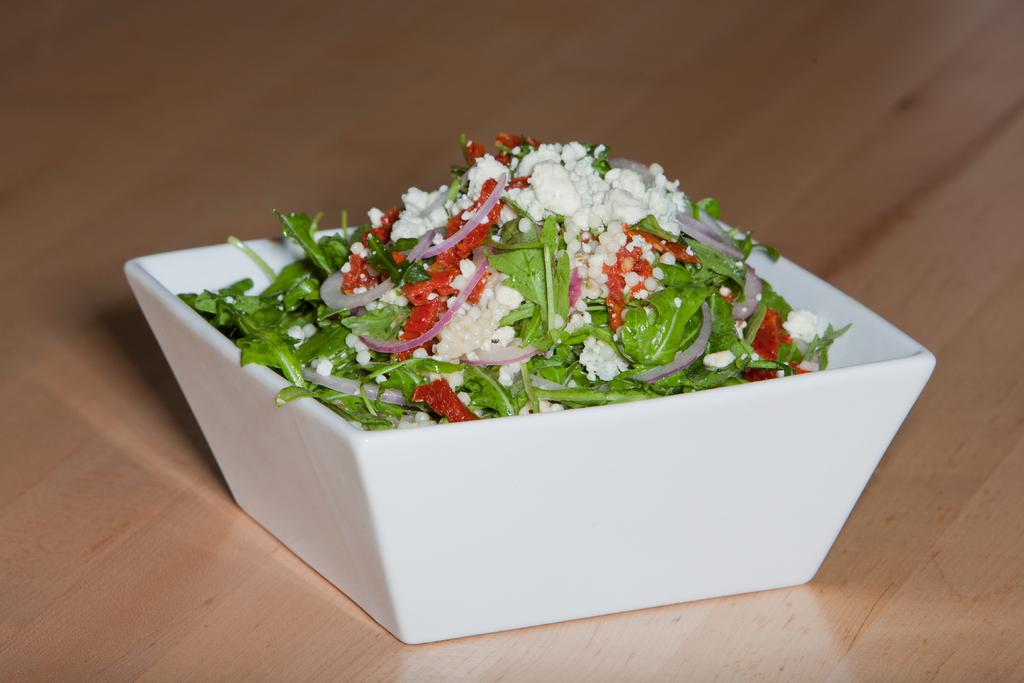What is located in the center of the image? There is a table in the center of the image. What is placed on the table? There is a bowl on the table. What can be found inside the bowl? There are food items in the bowl. What type of news can be seen on the calculator in the image? There is no calculator or news present in the image. Can you tell me how many robins are sitting on the table in the image? There are no robins present in the image; it only features a table, a bowl, and food items. 